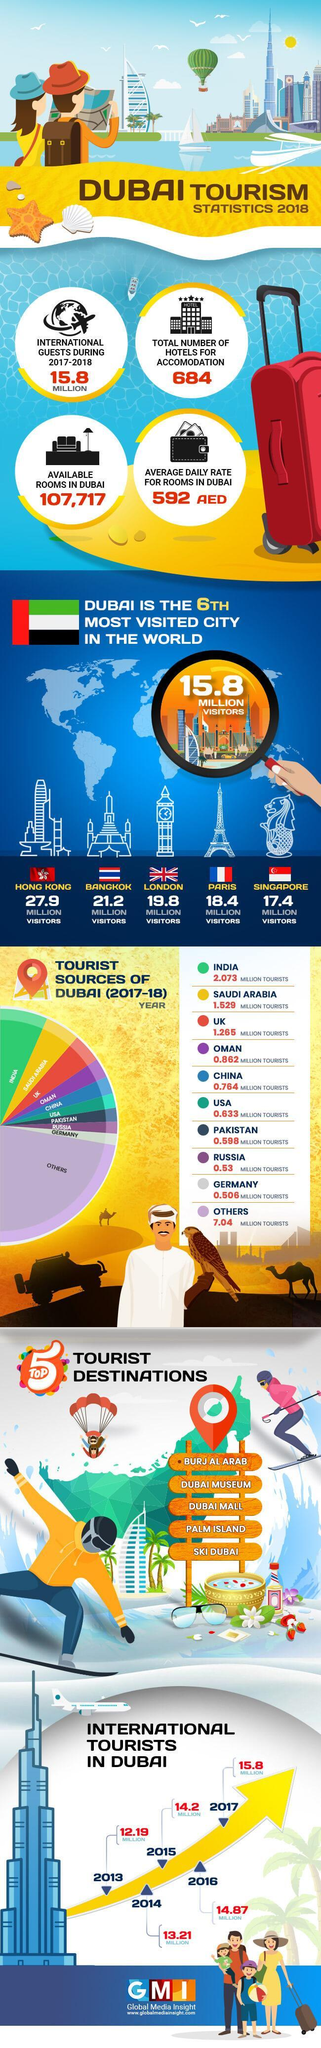Tourists from which country visited Dubai the most during 2017-2018?
Answer the question with a short phrase. INDIA By what number did international tourists increase from 2013 to 2017? 3.61 MILLION How many more visitors do Hong Kong get than Dubai? 12.1 MILLION VISITORS On the pie chart, which country is represented by yellow colour? SAUDI ARABIA How many flags are shown in the infographic? 6 What is the difference in number of visitors from Saudi Arabia and UK? 0.264 MILLION VISITORS 